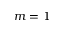<formula> <loc_0><loc_0><loc_500><loc_500>m = 1</formula> 